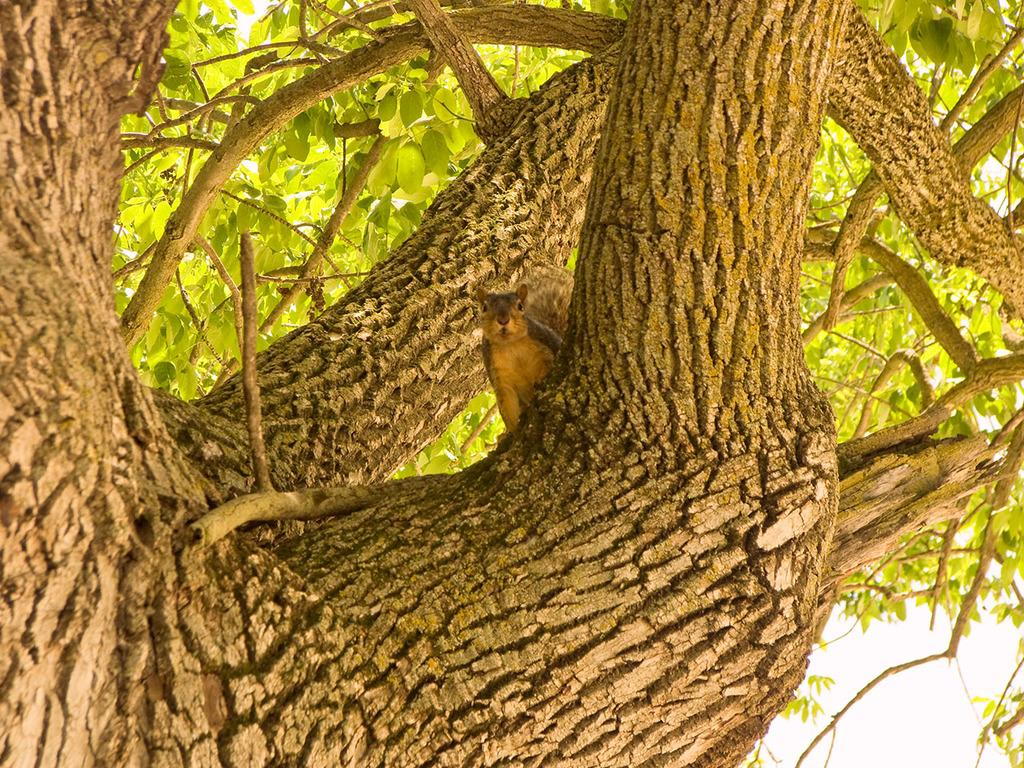What type of plant can be seen in the image? There is a tree in the image. What animal is present in the image? There is a squirrel in the image. What type of quiver can be seen in the image? There is no quiver present in the image. Is there a volleyball game happening in the image? There is no volleyball game or any reference to a volleyball in the image. 